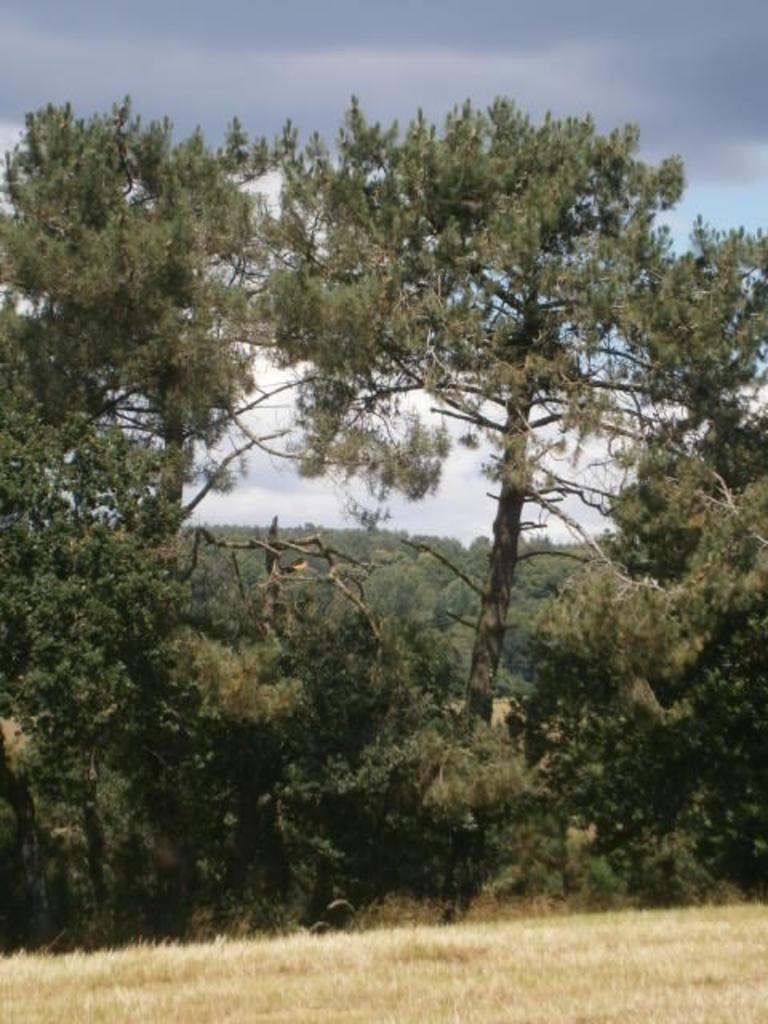What type of vegetation is present in the image? There are trees in the image. What covers the ground in the image? There is grass on the ground in the image. What is visible at the top of the image? The sky is visible at the top of the image. Can you see any fingers in the image? There are no fingers visible in the image. Is there any indication of pain in the image? There is no indication of pain in the image. 